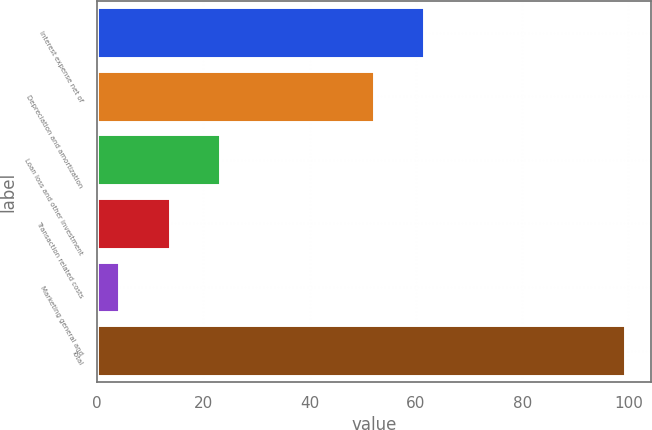<chart> <loc_0><loc_0><loc_500><loc_500><bar_chart><fcel>Interest expense net of<fcel>Depreciation and amortization<fcel>Loan loss and other investment<fcel>Transaction related costs<fcel>Marketing general and<fcel>Total<nl><fcel>61.61<fcel>52.1<fcel>23.22<fcel>13.71<fcel>4.2<fcel>99.3<nl></chart> 